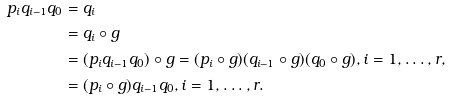Convert formula to latex. <formula><loc_0><loc_0><loc_500><loc_500>p _ { i } q _ { i - 1 } q _ { 0 } & = q _ { i } \\ & = q _ { i } \circ g \\ & = ( p _ { i } q _ { i - 1 } q _ { 0 } ) \circ g = ( p _ { i } \circ g ) ( q _ { i - 1 } \circ g ) ( q _ { 0 } \circ g ) , i = 1 , \dots , r , \\ & = ( p _ { i } \circ g ) q _ { i - 1 } q _ { 0 } , i = 1 , \dots , r .</formula> 